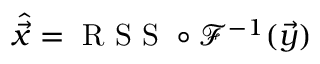<formula> <loc_0><loc_0><loc_500><loc_500>\hat { \vec { x } } = R S S \circ \mathcal { F } ^ { - 1 } ( \vec { y } )</formula> 